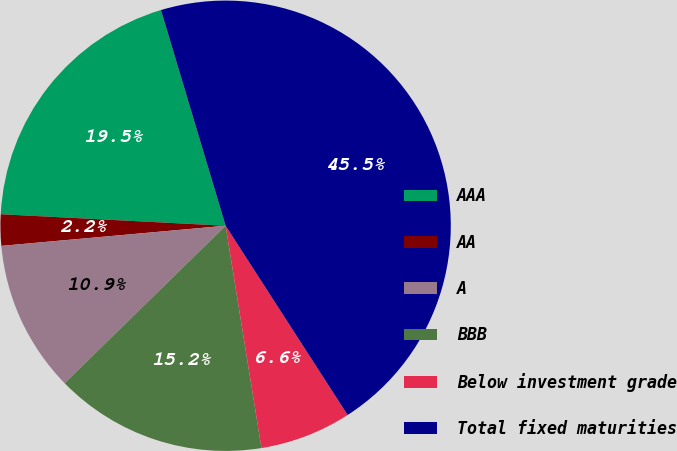Convert chart to OTSL. <chart><loc_0><loc_0><loc_500><loc_500><pie_chart><fcel>AAA<fcel>AA<fcel>A<fcel>BBB<fcel>Below investment grade<fcel>Total fixed maturities<nl><fcel>19.55%<fcel>2.24%<fcel>10.9%<fcel>15.22%<fcel>6.57%<fcel>45.52%<nl></chart> 